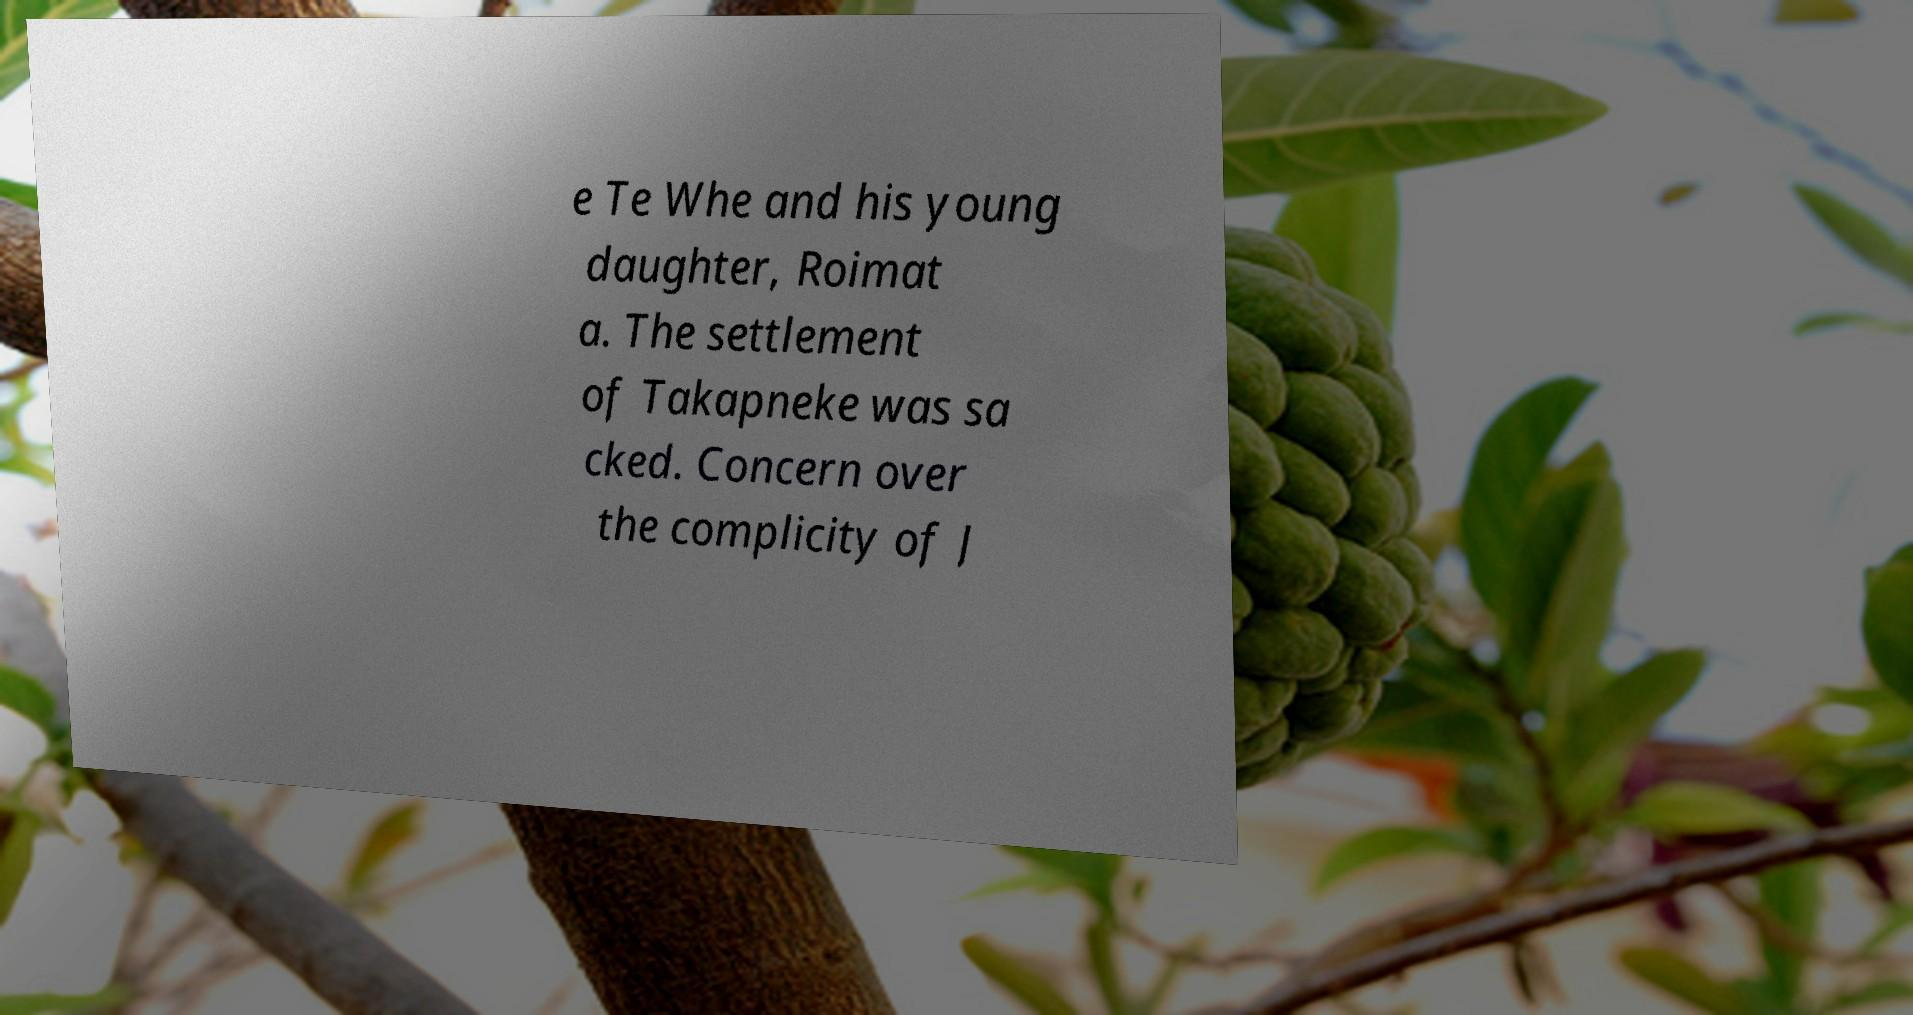Please read and relay the text visible in this image. What does it say? e Te Whe and his young daughter, Roimat a. The settlement of Takapneke was sa cked. Concern over the complicity of J 